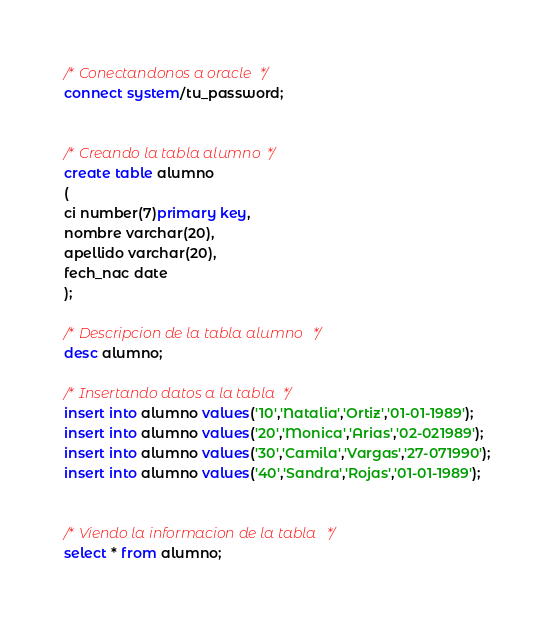<code> <loc_0><loc_0><loc_500><loc_500><_SQL_>
/* Conectandonos a oracle */
connect system/tu_password;


/* Creando la tabla alumno */
create table alumno
(
ci number(7)primary key,
nombre varchar(20),
apellido varchar(20),
fech_nac date
);

/* Descripcion de la tabla alumno */
desc alumno;

/* Insertando datos a la tabla */
insert into alumno values('10','Natalia','Ortiz','01-01-1989');
insert into alumno values('20','Monica','Arias','02-021989');
insert into alumno values('30','Camila','Vargas','27-071990');
insert into alumno values('40','Sandra','Rojas','01-01-1989');
 
 
/* Viendo la informacion de la tabla */
select * from alumno;</code> 